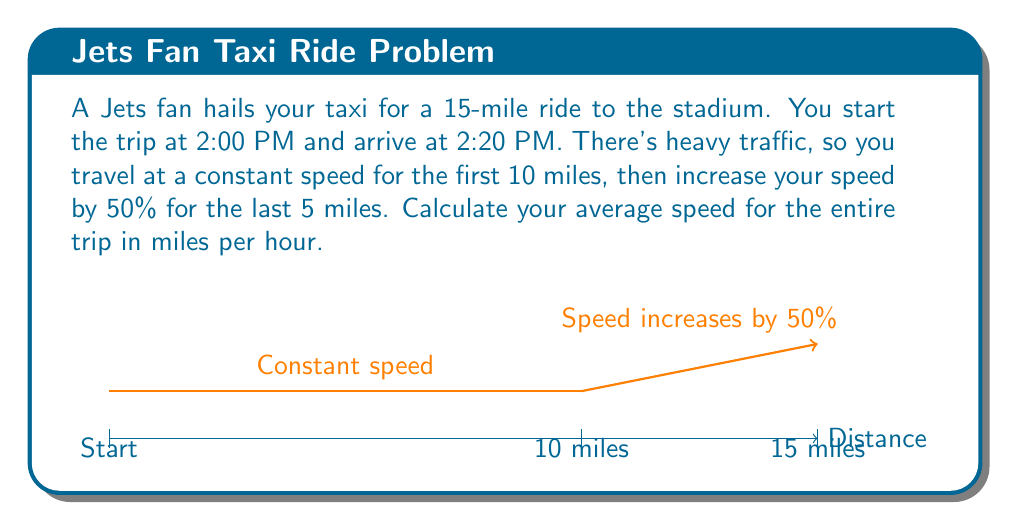Show me your answer to this math problem. Let's approach this step-by-step:

1) First, calculate the total time of the trip:
   2:20 PM - 2:00 PM = 20 minutes = $\frac{1}{3}$ hour

2) Let $x$ be the initial speed in miles per hour. Then $1.5x$ is the increased speed.

3) Set up an equation based on the distance covered:
   $$\frac{10}{x} + \frac{5}{1.5x} = \frac{1}{3}$$

4) Simplify the equation:
   $$\frac{15}{x} + \frac{10}{3x} = \frac{1}{3}$$
   $$\frac{45}{3x} + \frac{10}{3x} = \frac{1}{3}$$
   $$\frac{55}{3x} = \frac{1}{3}$$

5) Solve for $x$:
   $$x = 55$$

6) The average speed is total distance divided by total time:
   $$\text{Average Speed} = \frac{15 \text{ miles}}{\frac{1}{3} \text{ hour}} = 45 \text{ mph}$$

Therefore, the average speed for the entire trip is 45 mph.
Answer: 45 mph 